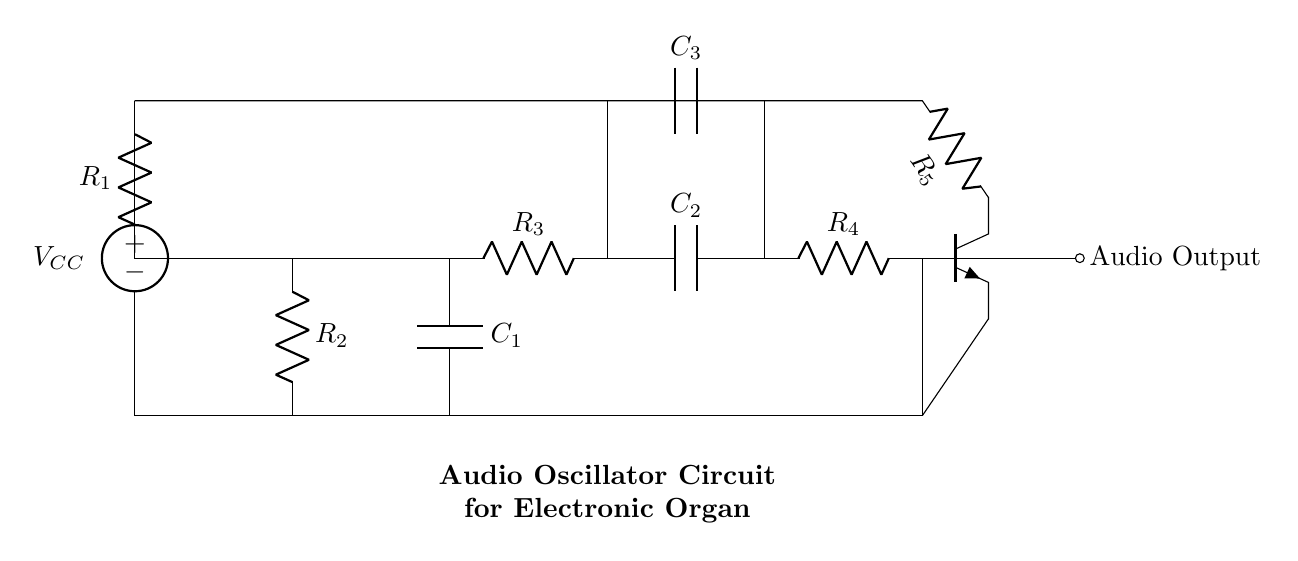What is the power supply voltage in this circuit? The circuit specifies a voltage source labeled as VCC (V subscript CC), indicated at the top left, which represents the power supply voltage.
Answer: VCC What are the resistors present in this circuit? There are four resistors labeled R1, R2, R3, and R4, which are connected in various parts of the circuit.
Answer: R1, R2, R3, R4 Which components are responsible for the frequency generation in this oscillator? The capacitors C1, C2, and C3, along with resistors R3 and R4, form part of the feedback network that determines the oscillation frequency.
Answer: C1, C2, C3, R3, R4 What type of transistor is used in this circuit? The circuit diagram features an NPN transistor symbol, indicating that the device used is an NPN type.
Answer: NPN How does the audio output connect to the circuit? The audio output is indicated as a connection point on the right side of the circuit, which suggests it takes the signal after amplification and filtering has occurred.
Answer: Audio Output What is the role of capacitors in this oscillator circuit? Capacitors in this circuit store and release electrical energy, participating in oscillation by determining the charging and discharging cycles which affect frequency.
Answer: Frequency determination What is the configuration of the transistor in this oscillator circuit? The configuration is common emitter, as the transistor's emitter is connected to the ground and it amplifies the input signal from its base to the collector, powering the output stage.
Answer: Common emitter 